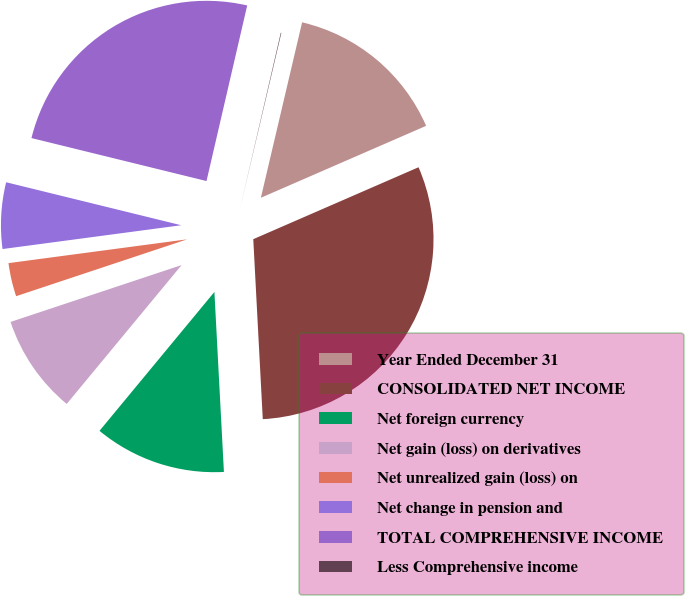<chart> <loc_0><loc_0><loc_500><loc_500><pie_chart><fcel>Year Ended December 31<fcel>CONSOLIDATED NET INCOME<fcel>Net foreign currency<fcel>Net gain (loss) on derivatives<fcel>Net unrealized gain (loss) on<fcel>Net change in pension and<fcel>TOTAL COMPREHENSIVE INCOME<fcel>Less Comprehensive income<nl><fcel>14.79%<fcel>30.69%<fcel>11.84%<fcel>8.89%<fcel>3.0%<fcel>5.94%<fcel>24.79%<fcel>0.05%<nl></chart> 